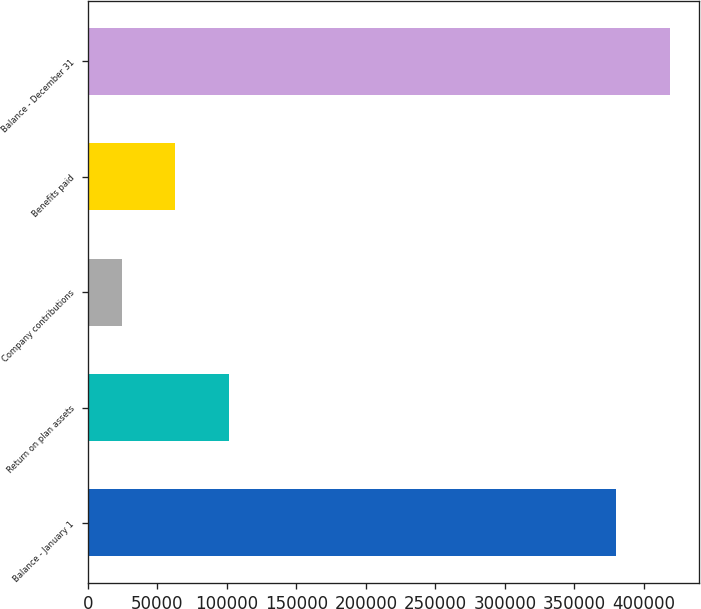Convert chart to OTSL. <chart><loc_0><loc_0><loc_500><loc_500><bar_chart><fcel>Balance - January 1<fcel>Return on plan assets<fcel>Company contributions<fcel>Benefits paid<fcel>Balance - December 31<nl><fcel>380342<fcel>101448<fcel>24194<fcel>62820.8<fcel>418969<nl></chart> 